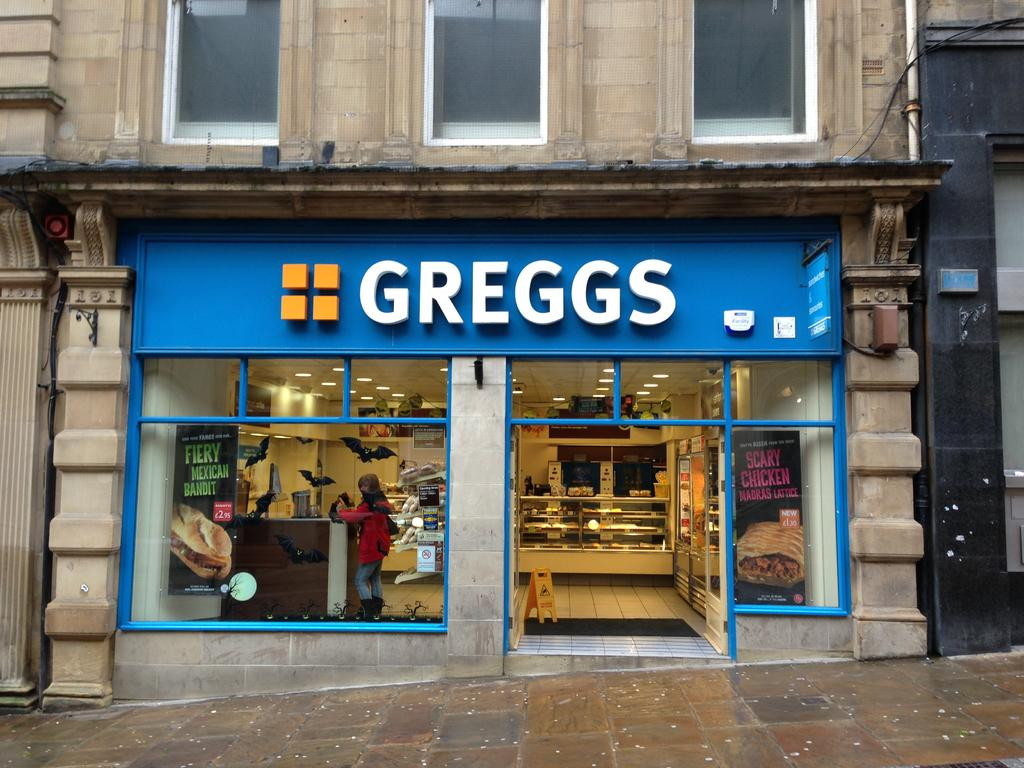What can be seen in the image that provides illumination? There are lights visible in the image. Where is the woman located in the image? The woman is in a store in the image. What architectural feature can be seen on a building in the image? There is a pipe on a building in the image. How many roses are hanging from the pipe in the image? There are no roses present in the image; it features lights, a woman in a store, and a pipe on a building. Are there any spiders crawling on the woman in the image? There is no mention of spiders in the image, and therefore no such activity can be observed. 